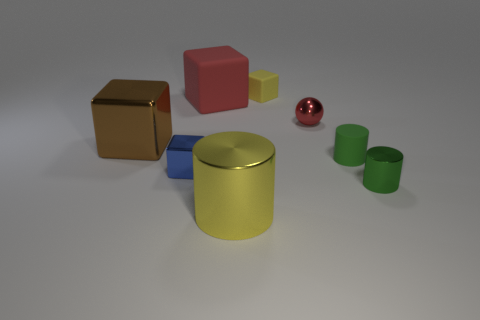Add 1 big gray matte cylinders. How many objects exist? 9 Subtract all yellow matte cubes. How many cubes are left? 3 Subtract 4 blocks. How many blocks are left? 0 Subtract all green cylinders. How many cylinders are left? 1 Subtract all cylinders. How many objects are left? 5 Subtract all large metallic cylinders. Subtract all tiny shiny spheres. How many objects are left? 6 Add 5 blue metal cubes. How many blue metal cubes are left? 6 Add 4 gray matte things. How many gray matte things exist? 4 Subtract 0 red cylinders. How many objects are left? 8 Subtract all green cylinders. Subtract all brown blocks. How many cylinders are left? 1 